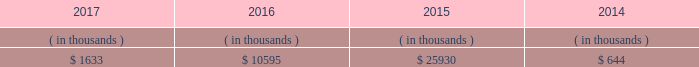Entergy mississippi may refinance , redeem , or otherwise retire debt and preferred stock prior to maturity , to the extent market conditions and interest and dividend rates are favorable .
All debt and common and preferred stock issuances by entergy mississippi require prior regulatory approval . a0 a0preferred stock and debt issuances are also subject to issuance tests set forth in its corporate charter , bond indenture , and other agreements . a0 a0entergy mississippi has sufficient capacity under these tests to meet its foreseeable capital needs .
Entergy mississippi 2019s receivables from the money pool were as follows as of december 31 for each of the following years. .
See note 4 to the financial statements for a description of the money pool .
Entergy mississippi has four separate credit facilities in the aggregate amount of $ 102.5 million scheduled to expire may 2018 .
No borrowings were outstanding under the credit facilities as of december a031 , 2017 . a0 a0in addition , entergy mississippi is a party to an uncommitted letter of credit facility as a means to post collateral to support its obligations to miso .
As of december a031 , 2017 , a $ 15.3 million letter of credit was outstanding under entergy mississippi 2019s uncommitted letter of credit facility .
See note 4 to the financial statements for additional discussion of the credit facilities .
Entergy mississippi obtained authorizations from the ferc through october 2019 for short-term borrowings not to exceed an aggregate amount of $ 175 million at any time outstanding and long-term borrowings and security issuances .
See note 4 to the financial statements for further discussion of entergy mississippi 2019s short-term borrowing limits .
Entergy mississippi , inc .
Management 2019s financial discussion and analysis state and local rate regulation and fuel-cost recovery the rates that entergy mississippi charges for electricity significantly influence its financial position , results of operations , and liquidity .
Entergy mississippi is regulated and the rates charged to its customers are determined in regulatory proceedings .
A governmental agency , the mpsc , is primarily responsible for approval of the rates charged to customers .
Formula rate plan in march 2016 , entergy mississippi submitted its formula rate plan 2016 test year filing showing entergy mississippi 2019s projected earned return for the 2016 calendar year to be below the formula rate plan bandwidth .
The filing showed a $ 32.6 million rate increase was necessary to reset entergy mississippi 2019s earned return on common equity to the specified point of adjustment of 9.96% ( 9.96 % ) , within the formula rate plan bandwidth .
In june 2016 the mpsc approved entergy mississippi 2019s joint stipulation with the mississippi public utilities staff .
The joint stipulation provided for a total revenue increase of $ 23.7 million .
The revenue increase includes a $ 19.4 million increase through the formula rate plan , resulting in a return on common equity point of adjustment of 10.07% ( 10.07 % ) .
The revenue increase also includes $ 4.3 million in incremental ad valorem tax expenses to be collected through an updated ad valorem tax adjustment rider .
The revenue increase and ad valorem tax adjustment rider were effective with the july 2016 bills .
In march 2017 , entergy mississippi submitted its formula rate plan 2017 test year filing and 2016 look-back filing showing entergy mississippi 2019s earned return for the historical 2016 calendar year and projected earned return for the 2017 calendar year to be within the formula rate plan bandwidth , resulting in no change in rates .
In june 2017 , entergy mississippi and the mississippi public utilities staff entered into a stipulation that confirmed that entergy .
What percent of the 2016 money pool receivables was the 2017 receivables? 
Computations: (1633 / 10595)
Answer: 0.15413. 